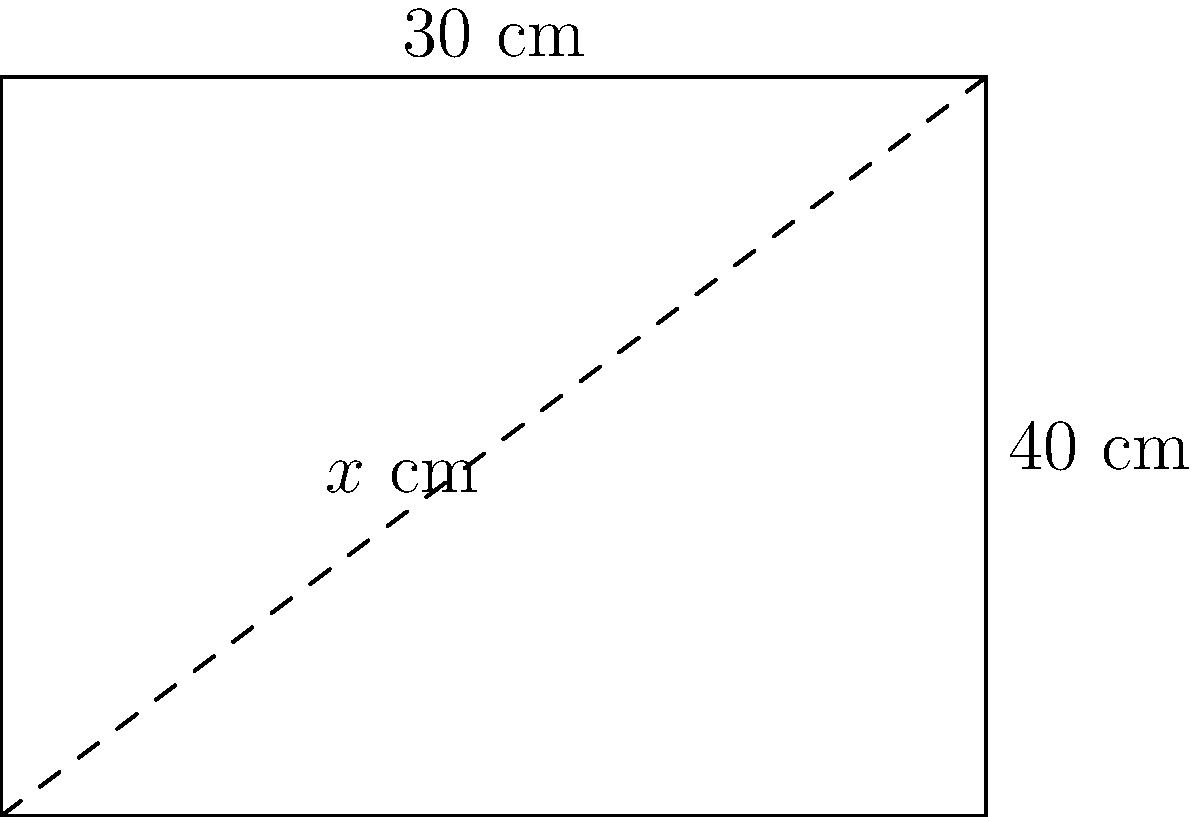As a diabetes support group organizer promoting healthy meal prep, you're advising on kitchen tools. A rectangular cutting board measures 40 cm in length and 30 cm in width. What is the length of the diagonal, $x$, in centimeters? Round your answer to the nearest tenth. To find the length of the diagonal of the rectangular cutting board, we can use the Pythagorean theorem:

1) Let the diagonal length be $x$ cm.
2) The Pythagorean theorem states: $a^2 + b^2 = c^2$, where $c$ is the hypotenuse (diagonal in this case).
3) Substituting the known values:
   $40^2 + 30^2 = x^2$
4) Simplify:
   $1600 + 900 = x^2$
   $2500 = x^2$
5) Take the square root of both sides:
   $\sqrt{2500} = x$
6) Simplify:
   $x = 50$ cm

Therefore, the diagonal length is 50 cm.
Answer: 50 cm 